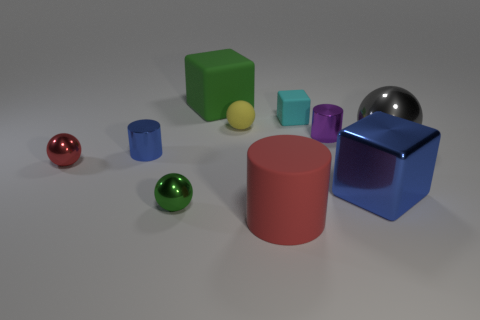The other metal object that is the same shape as the small purple thing is what size?
Provide a succinct answer. Small. What color is the large rubber thing that is the same shape as the small blue object?
Offer a very short reply. Red. How many other things are there of the same material as the tiny cyan cube?
Your answer should be very brief. 3. Are there the same number of big blue cubes behind the small cyan matte object and cylinders in front of the green metallic ball?
Provide a short and direct response. No. What is the color of the small metallic cylinder on the right side of the large block behind the cylinder that is on the right side of the rubber cylinder?
Provide a succinct answer. Purple. What is the shape of the red object that is on the left side of the big red object?
Offer a terse response. Sphere. The tiny purple object that is the same material as the small red sphere is what shape?
Provide a succinct answer. Cylinder. Are there any other things that have the same shape as the purple object?
Your response must be concise. Yes. There is a purple shiny cylinder; what number of purple metal things are on the left side of it?
Offer a very short reply. 0. Are there an equal number of tiny green metal objects that are behind the cyan matte thing and small purple metallic cylinders?
Your response must be concise. No. 